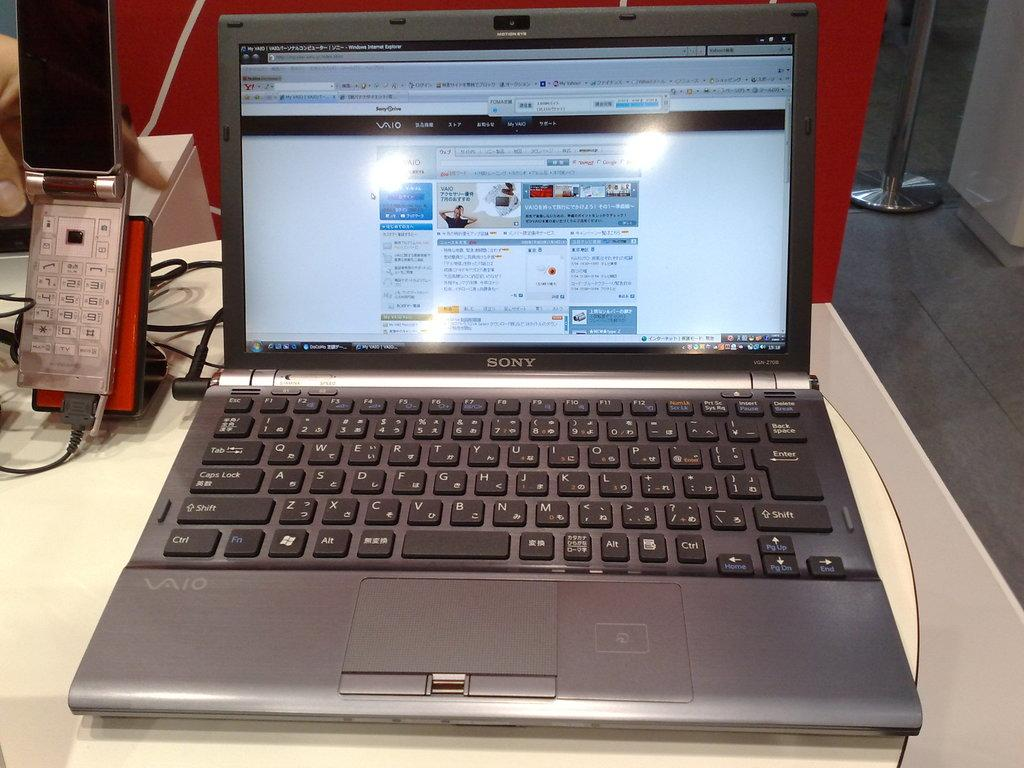<image>
Give a short and clear explanation of the subsequent image. A desk features a silver Sony laptop and a flip phone next to it. 